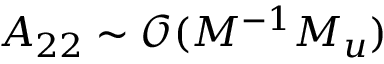<formula> <loc_0><loc_0><loc_500><loc_500>A _ { 2 2 } \sim \mathcal { O } ( M ^ { - 1 } M _ { u } )</formula> 